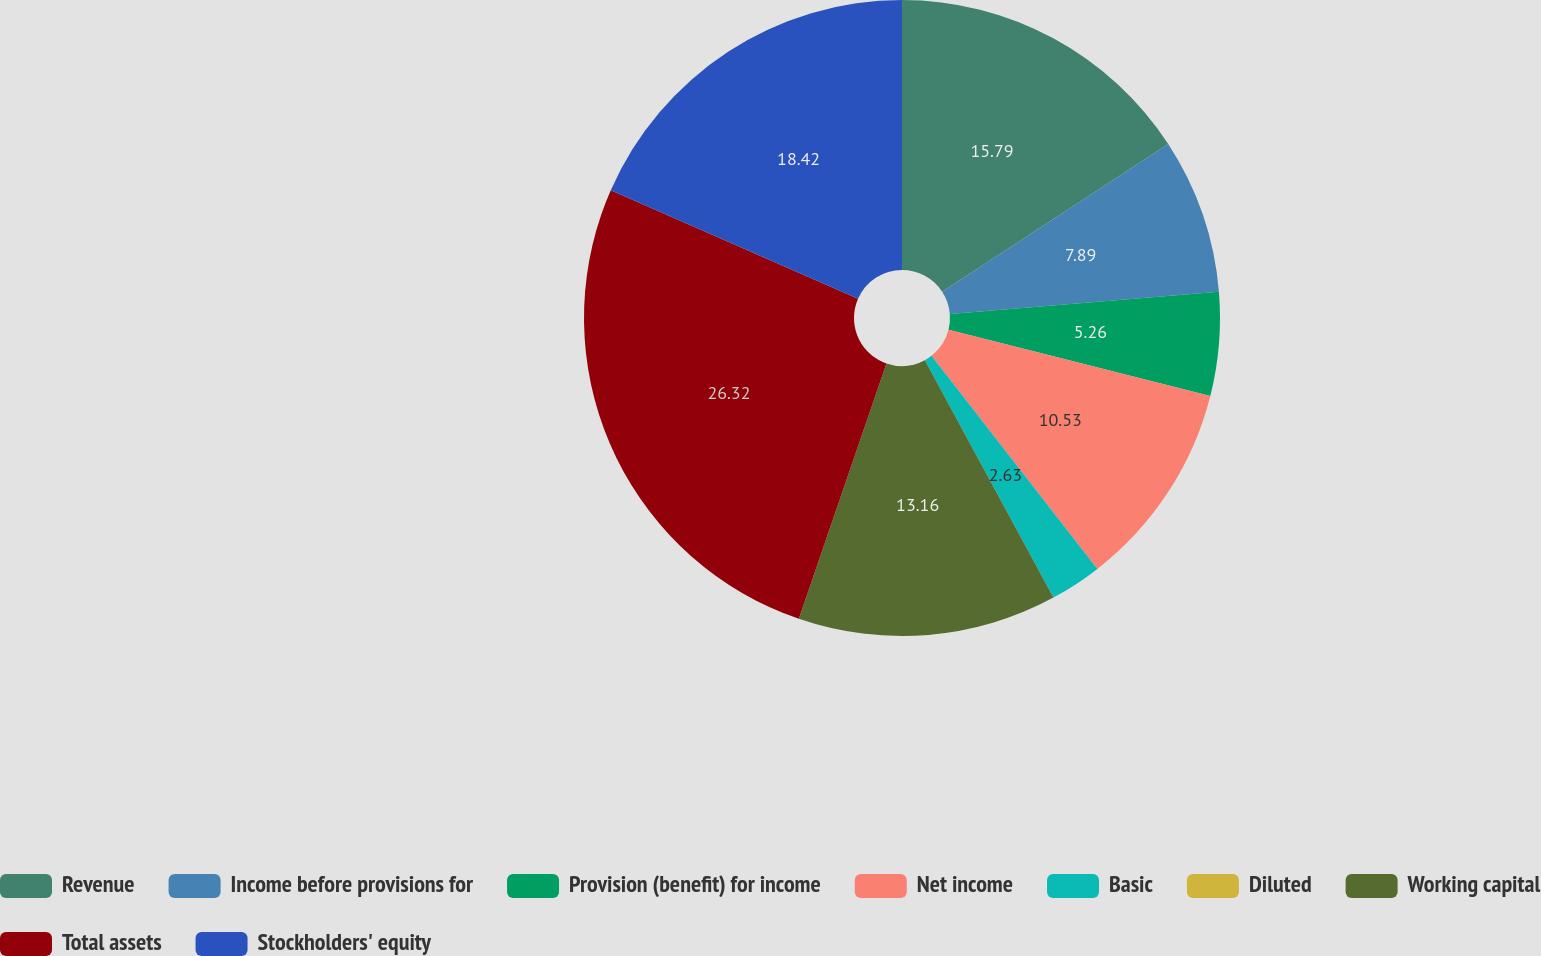Convert chart to OTSL. <chart><loc_0><loc_0><loc_500><loc_500><pie_chart><fcel>Revenue<fcel>Income before provisions for<fcel>Provision (benefit) for income<fcel>Net income<fcel>Basic<fcel>Diluted<fcel>Working capital<fcel>Total assets<fcel>Stockholders' equity<nl><fcel>15.79%<fcel>7.89%<fcel>5.26%<fcel>10.53%<fcel>2.63%<fcel>0.0%<fcel>13.16%<fcel>26.32%<fcel>18.42%<nl></chart> 